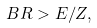Convert formula to latex. <formula><loc_0><loc_0><loc_500><loc_500>B R > E / Z ,</formula> 